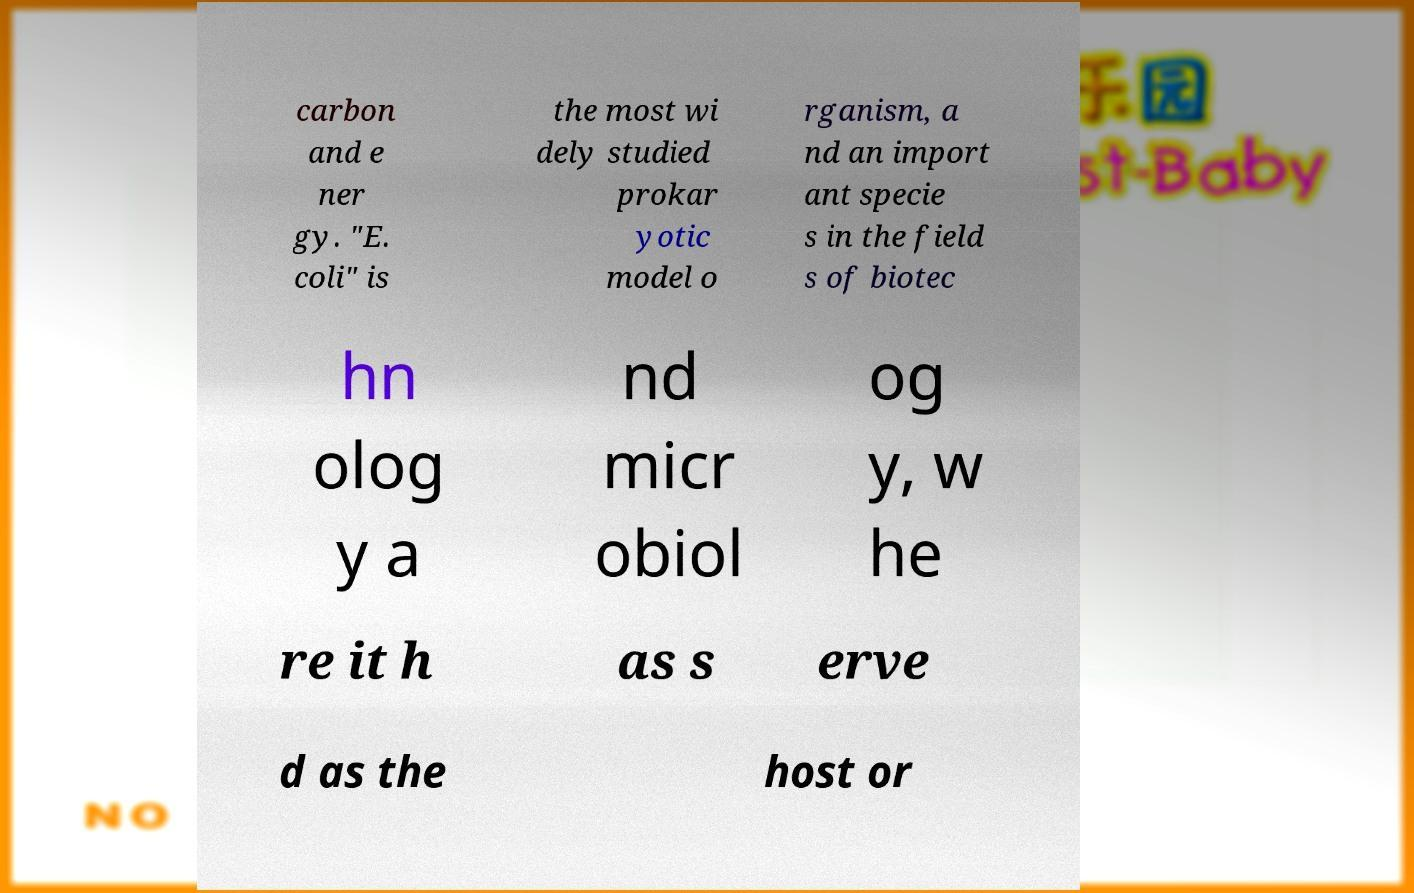Please identify and transcribe the text found in this image. carbon and e ner gy. "E. coli" is the most wi dely studied prokar yotic model o rganism, a nd an import ant specie s in the field s of biotec hn olog y a nd micr obiol og y, w he re it h as s erve d as the host or 